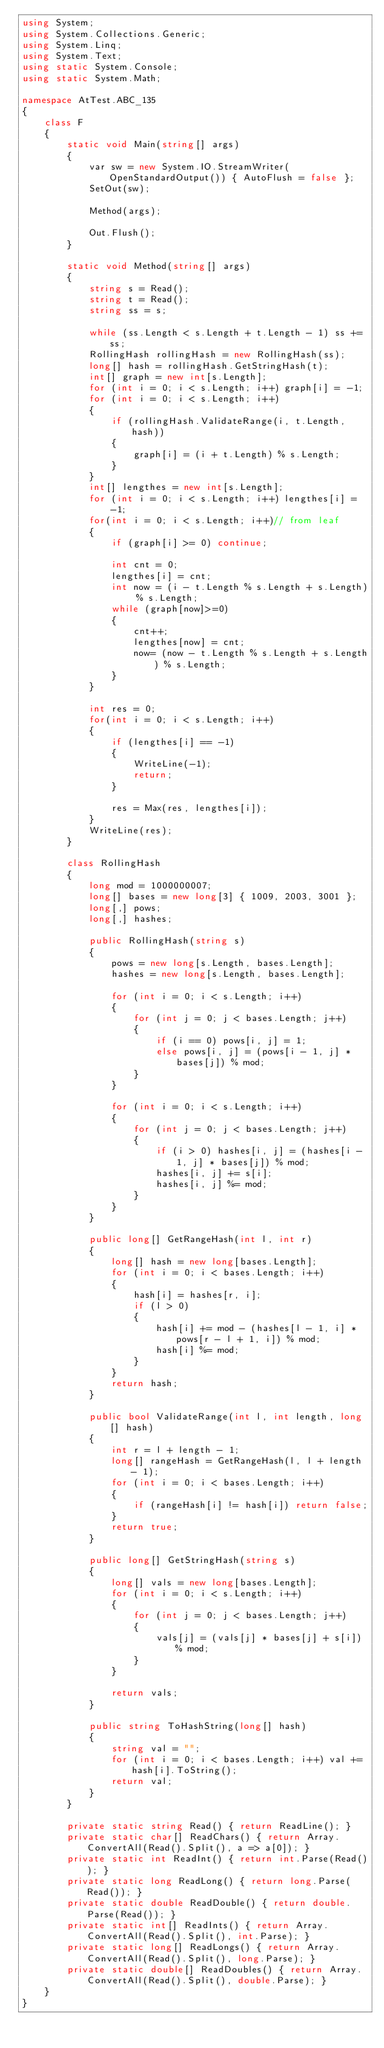<code> <loc_0><loc_0><loc_500><loc_500><_C#_>using System;
using System.Collections.Generic;
using System.Linq;
using System.Text;
using static System.Console;
using static System.Math;

namespace AtTest.ABC_135
{
    class F
    {
        static void Main(string[] args)
        {
            var sw = new System.IO.StreamWriter(OpenStandardOutput()) { AutoFlush = false };
            SetOut(sw);

            Method(args);

            Out.Flush();
        }

        static void Method(string[] args)
        {
            string s = Read();
            string t = Read();
            string ss = s;

            while (ss.Length < s.Length + t.Length - 1) ss += ss;
            RollingHash rollingHash = new RollingHash(ss);
            long[] hash = rollingHash.GetStringHash(t);
            int[] graph = new int[s.Length];
            for (int i = 0; i < s.Length; i++) graph[i] = -1;
            for (int i = 0; i < s.Length; i++)
            {
                if (rollingHash.ValidateRange(i, t.Length, hash))
                {
                    graph[i] = (i + t.Length) % s.Length;
                }
            }
            int[] lengthes = new int[s.Length];
            for (int i = 0; i < s.Length; i++) lengthes[i] = -1;
            for(int i = 0; i < s.Length; i++)// from leaf
            {
                if (graph[i] >= 0) continue;

                int cnt = 0;
                lengthes[i] = cnt;
                int now = (i - t.Length % s.Length + s.Length) % s.Length;
                while (graph[now]>=0)
                {
                    cnt++;
                    lengthes[now] = cnt;
                    now= (now - t.Length % s.Length + s.Length) % s.Length;
                }
            }

            int res = 0;
            for(int i = 0; i < s.Length; i++)
            {
                if (lengthes[i] == -1)
                {
                    WriteLine(-1);
                    return;
                }

                res = Max(res, lengthes[i]);
            }
            WriteLine(res);
        }

        class RollingHash
        {
            long mod = 1000000007;
            long[] bases = new long[3] { 1009, 2003, 3001 };
            long[,] pows;
            long[,] hashes;

            public RollingHash(string s)
            {
                pows = new long[s.Length, bases.Length];
                hashes = new long[s.Length, bases.Length];

                for (int i = 0; i < s.Length; i++)
                {
                    for (int j = 0; j < bases.Length; j++)
                    {
                        if (i == 0) pows[i, j] = 1;
                        else pows[i, j] = (pows[i - 1, j] * bases[j]) % mod;
                    }
                }

                for (int i = 0; i < s.Length; i++)
                {
                    for (int j = 0; j < bases.Length; j++)
                    {
                        if (i > 0) hashes[i, j] = (hashes[i - 1, j] * bases[j]) % mod;
                        hashes[i, j] += s[i];
                        hashes[i, j] %= mod;
                    }
                }
            }

            public long[] GetRangeHash(int l, int r)
            {
                long[] hash = new long[bases.Length];
                for (int i = 0; i < bases.Length; i++)
                {
                    hash[i] = hashes[r, i];
                    if (l > 0)
                    {
                        hash[i] += mod - (hashes[l - 1, i] * pows[r - l + 1, i]) % mod;
                        hash[i] %= mod;
                    }
                }
                return hash;
            }

            public bool ValidateRange(int l, int length, long[] hash)
            {
                int r = l + length - 1;
                long[] rangeHash = GetRangeHash(l, l + length - 1);
                for (int i = 0; i < bases.Length; i++)
                {
                    if (rangeHash[i] != hash[i]) return false;
                }
                return true;
            }

            public long[] GetStringHash(string s)
            {
                long[] vals = new long[bases.Length];
                for (int i = 0; i < s.Length; i++)
                {
                    for (int j = 0; j < bases.Length; j++)
                    {
                        vals[j] = (vals[j] * bases[j] + s[i]) % mod;
                    }
                }

                return vals;
            }

            public string ToHashString(long[] hash)
            {
                string val = "";
                for (int i = 0; i < bases.Length; i++) val += hash[i].ToString();
                return val;
            }
        }

        private static string Read() { return ReadLine(); }
        private static char[] ReadChars() { return Array.ConvertAll(Read().Split(), a => a[0]); }
        private static int ReadInt() { return int.Parse(Read()); }
        private static long ReadLong() { return long.Parse(Read()); }
        private static double ReadDouble() { return double.Parse(Read()); }
        private static int[] ReadInts() { return Array.ConvertAll(Read().Split(), int.Parse); }
        private static long[] ReadLongs() { return Array.ConvertAll(Read().Split(), long.Parse); }
        private static double[] ReadDoubles() { return Array.ConvertAll(Read().Split(), double.Parse); }
    }
}
</code> 